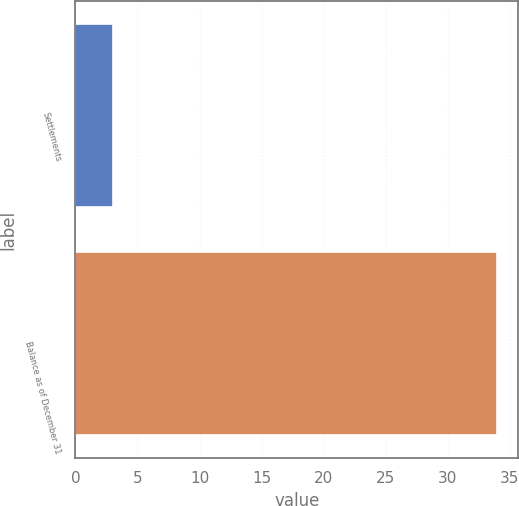<chart> <loc_0><loc_0><loc_500><loc_500><bar_chart><fcel>Settlements<fcel>Balance as of December 31<nl><fcel>3<fcel>34<nl></chart> 